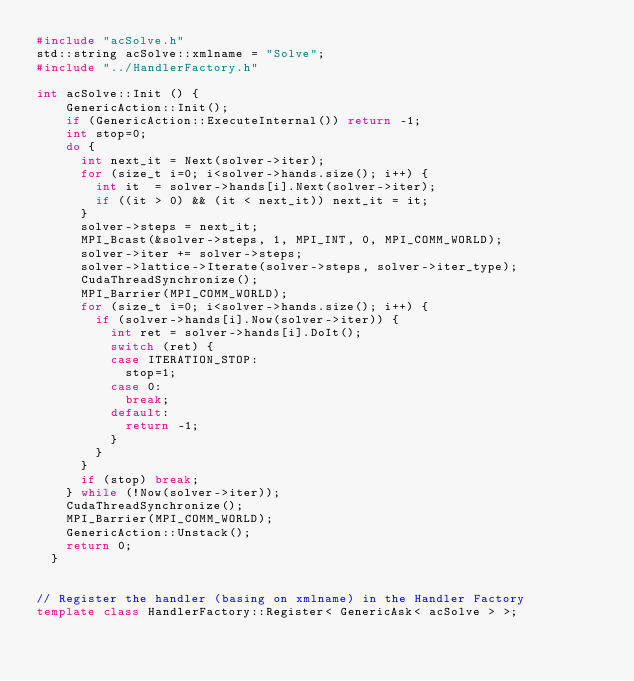<code> <loc_0><loc_0><loc_500><loc_500><_C++_>#include "acSolve.h"
std::string acSolve::xmlname = "Solve";
#include "../HandlerFactory.h"

int acSolve::Init () {
		GenericAction::Init();
		if (GenericAction::ExecuteInternal()) return -1;
		int stop=0;
		do {
			int next_it = Next(solver->iter);
			for (size_t i=0; i<solver->hands.size(); i++) {
				int it  = solver->hands[i].Next(solver->iter);
				if ((it > 0) && (it < next_it)) next_it = it;
			}
			solver->steps = next_it;
			MPI_Bcast(&solver->steps, 1, MPI_INT, 0, MPI_COMM_WORLD);
			solver->iter += solver->steps;
			solver->lattice->Iterate(solver->steps, solver->iter_type);
			CudaThreadSynchronize();
			MPI_Barrier(MPI_COMM_WORLD);
			for (size_t i=0; i<solver->hands.size(); i++) {
				if (solver->hands[i].Now(solver->iter)) {
					int ret = solver->hands[i].DoIt();
					switch (ret) {
					case ITERATION_STOP:
						stop=1;
					case 0:
						break;
					default:
						return -1;
					}
				}
			}
			if (stop) break;
		} while (!Now(solver->iter));
		CudaThreadSynchronize();
		MPI_Barrier(MPI_COMM_WORLD);
		GenericAction::Unstack();
		return 0;
	}


// Register the handler (basing on xmlname) in the Handler Factory
template class HandlerFactory::Register< GenericAsk< acSolve > >;
</code> 